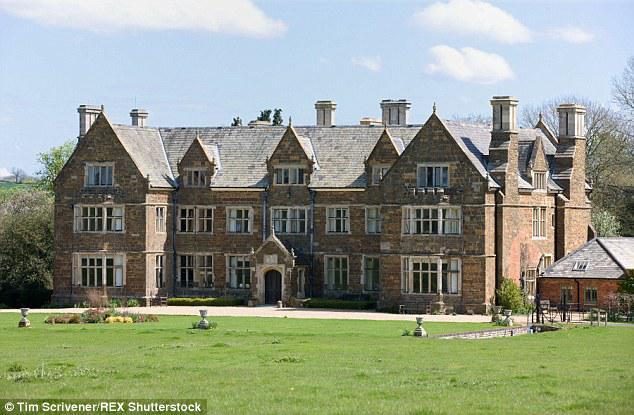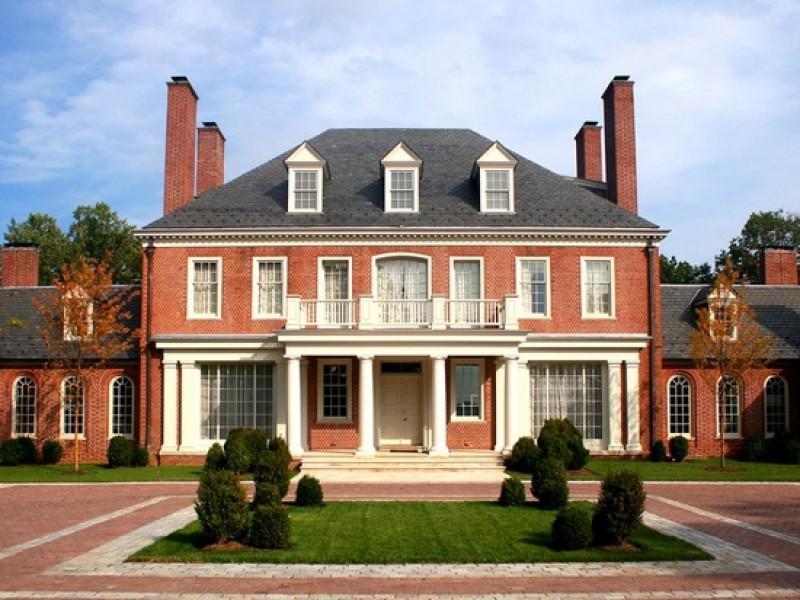The first image is the image on the left, the second image is the image on the right. Assess this claim about the two images: "There is no visible grass in at least one image.". Correct or not? Answer yes or no. No. 